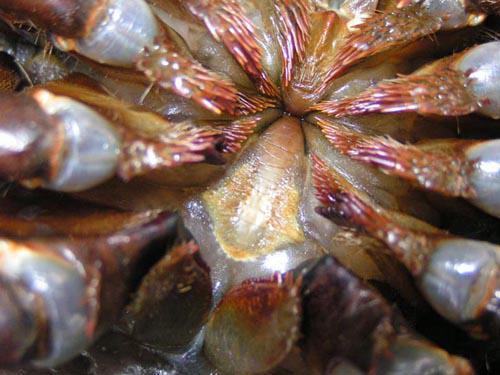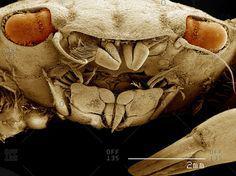The first image is the image on the left, the second image is the image on the right. For the images shown, is this caption "The right image shows the face of a shelled creature, and the left image shows an underside with some kind of appendages radiating from a center." true? Answer yes or no. Yes. 